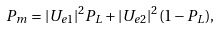Convert formula to latex. <formula><loc_0><loc_0><loc_500><loc_500>P _ { m } = | U _ { e 1 } | ^ { 2 } P _ { L } + | U _ { e 2 } | ^ { 2 } ( 1 - P _ { L } ) ,</formula> 